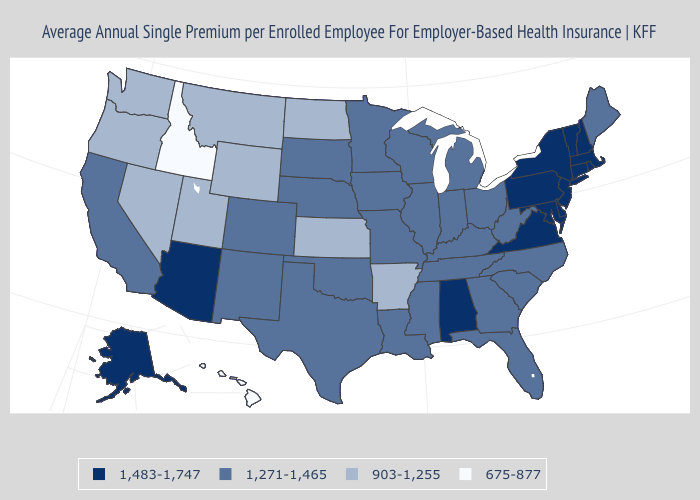Name the states that have a value in the range 903-1,255?
Concise answer only. Arkansas, Kansas, Montana, Nevada, North Dakota, Oregon, Utah, Washington, Wyoming. Does Hawaii have a lower value than Maryland?
Quick response, please. Yes. Which states hav the highest value in the South?
Give a very brief answer. Alabama, Delaware, Maryland, Virginia. Does the map have missing data?
Keep it brief. No. Is the legend a continuous bar?
Give a very brief answer. No. Does Alaska have the highest value in the West?
Keep it brief. Yes. Does Florida have a higher value than Hawaii?
Concise answer only. Yes. Does Arizona have the highest value in the West?
Be succinct. Yes. Which states hav the highest value in the West?
Answer briefly. Alaska, Arizona. Does the first symbol in the legend represent the smallest category?
Quick response, please. No. Name the states that have a value in the range 675-877?
Concise answer only. Hawaii, Idaho. Name the states that have a value in the range 1,483-1,747?
Give a very brief answer. Alabama, Alaska, Arizona, Connecticut, Delaware, Maryland, Massachusetts, New Hampshire, New Jersey, New York, Pennsylvania, Rhode Island, Vermont, Virginia. Does the first symbol in the legend represent the smallest category?
Quick response, please. No. Which states hav the highest value in the West?
Write a very short answer. Alaska, Arizona. What is the value of Maryland?
Concise answer only. 1,483-1,747. 